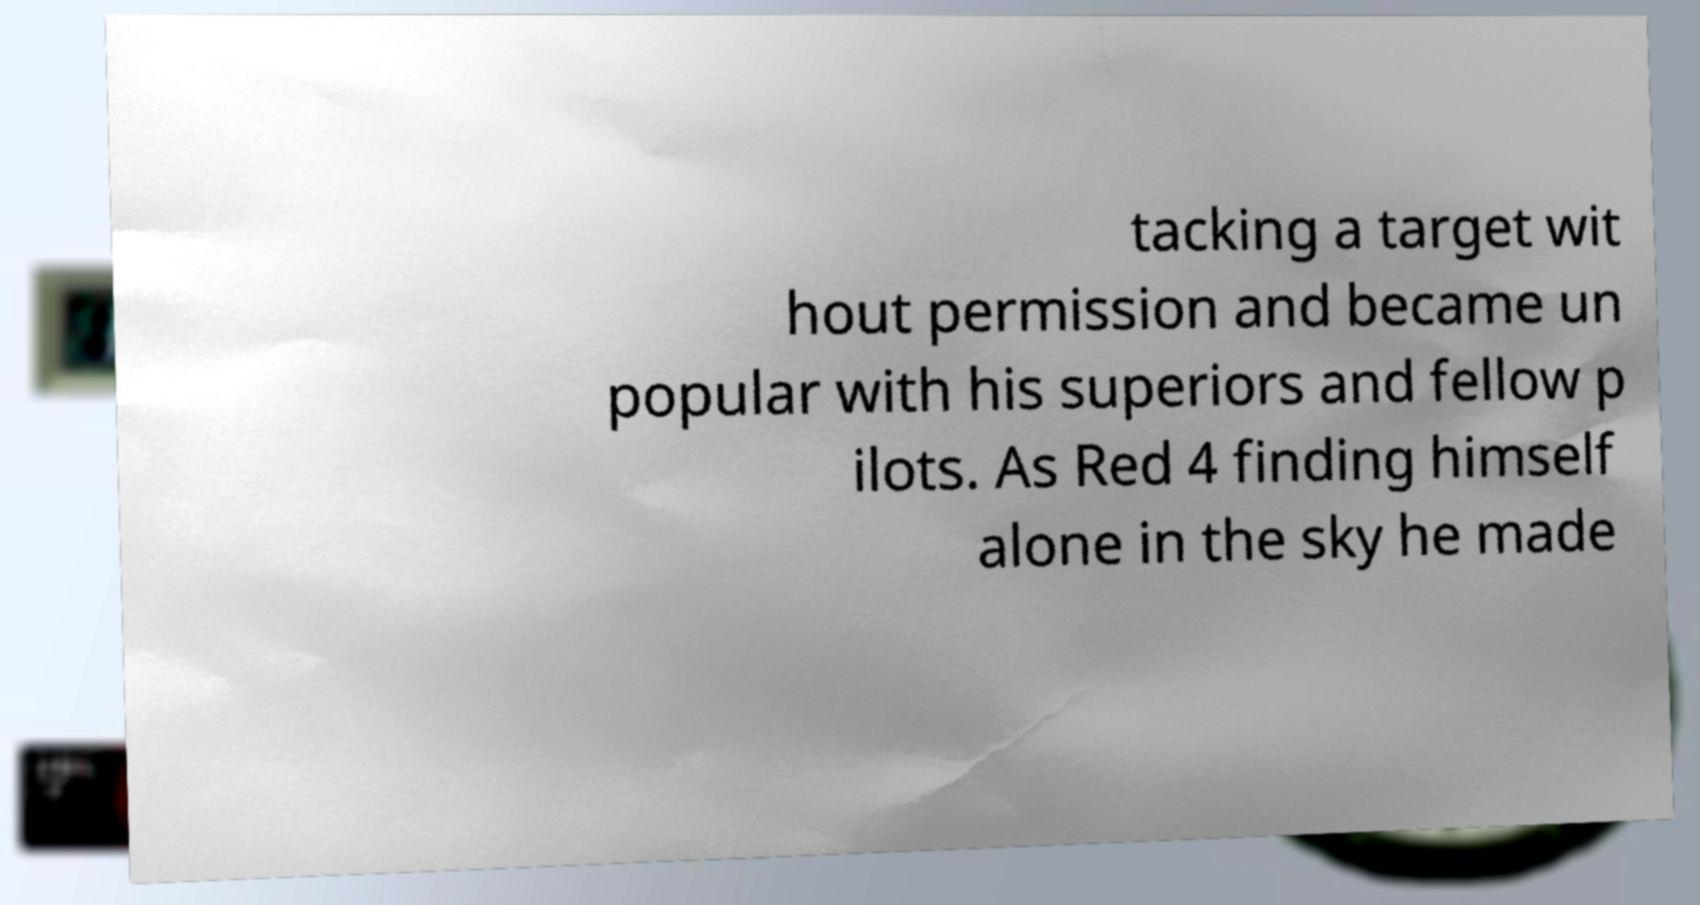There's text embedded in this image that I need extracted. Can you transcribe it verbatim? tacking a target wit hout permission and became un popular with his superiors and fellow p ilots. As Red 4 finding himself alone in the sky he made 